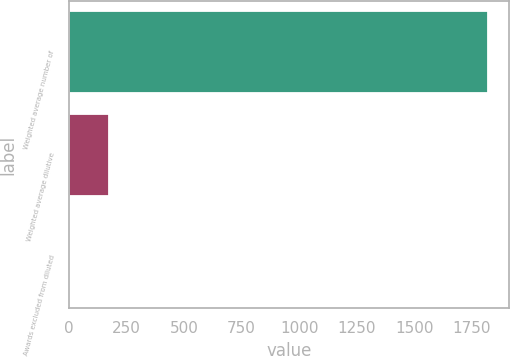Convert chart. <chart><loc_0><loc_0><loc_500><loc_500><bar_chart><fcel>Weighted average number of<fcel>Weighted average dilutive<fcel>Awards excluded from diluted<nl><fcel>1821.9<fcel>172.9<fcel>7<nl></chart> 